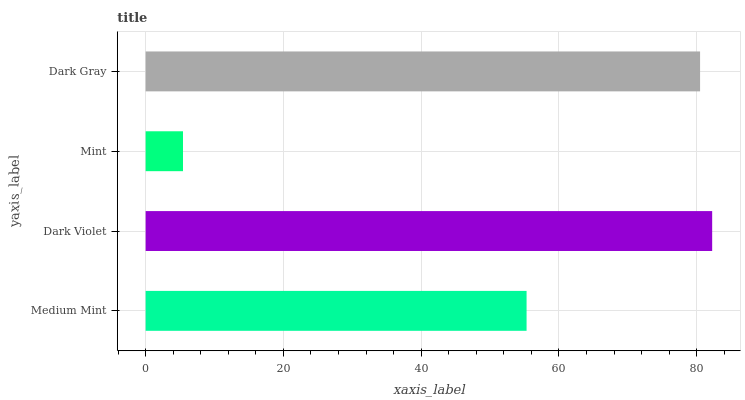Is Mint the minimum?
Answer yes or no. Yes. Is Dark Violet the maximum?
Answer yes or no. Yes. Is Dark Violet the minimum?
Answer yes or no. No. Is Mint the maximum?
Answer yes or no. No. Is Dark Violet greater than Mint?
Answer yes or no. Yes. Is Mint less than Dark Violet?
Answer yes or no. Yes. Is Mint greater than Dark Violet?
Answer yes or no. No. Is Dark Violet less than Mint?
Answer yes or no. No. Is Dark Gray the high median?
Answer yes or no. Yes. Is Medium Mint the low median?
Answer yes or no. Yes. Is Dark Violet the high median?
Answer yes or no. No. Is Dark Gray the low median?
Answer yes or no. No. 